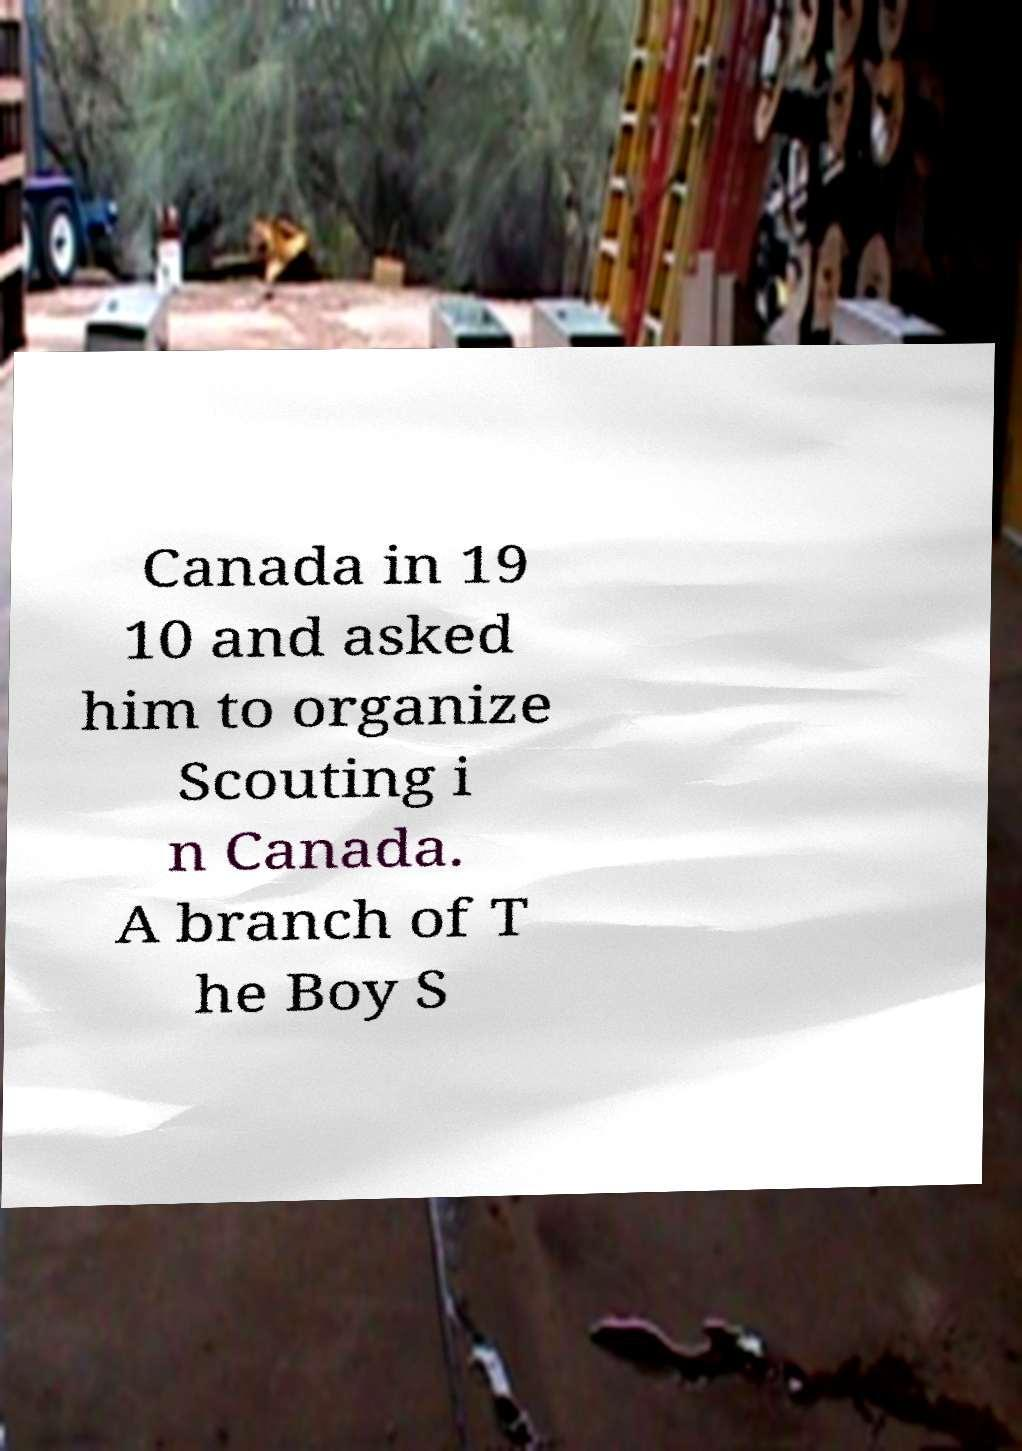Please identify and transcribe the text found in this image. Canada in 19 10 and asked him to organize Scouting i n Canada. A branch of T he Boy S 